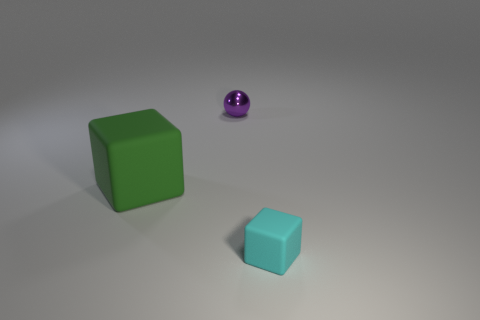Add 3 large green rubber objects. How many objects exist? 6 Subtract all cubes. How many objects are left? 1 Add 2 matte things. How many matte things exist? 4 Subtract 0 green cylinders. How many objects are left? 3 Subtract all big red matte spheres. Subtract all small purple metal spheres. How many objects are left? 2 Add 1 small cyan rubber objects. How many small cyan rubber objects are left? 2 